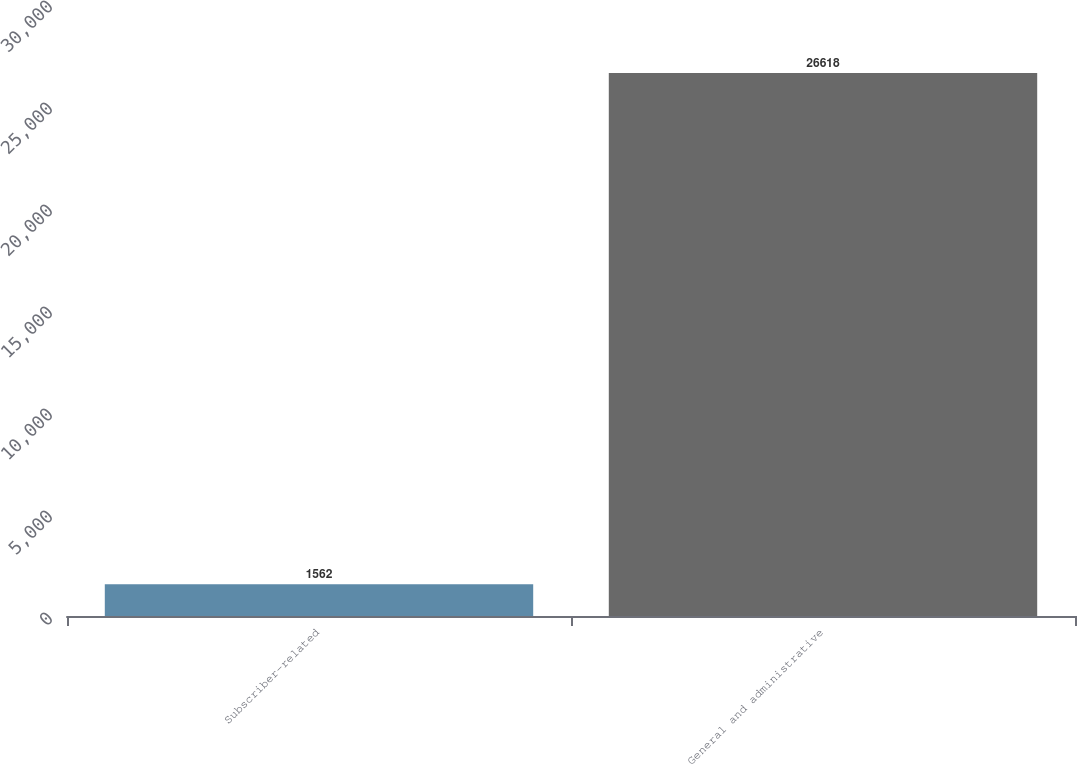<chart> <loc_0><loc_0><loc_500><loc_500><bar_chart><fcel>Subscriber-related<fcel>General and administrative<nl><fcel>1562<fcel>26618<nl></chart> 